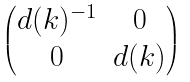<formula> <loc_0><loc_0><loc_500><loc_500>\begin{pmatrix} d ( k ) ^ { - 1 } & 0 \\ 0 & d ( k ) \end{pmatrix}</formula> 